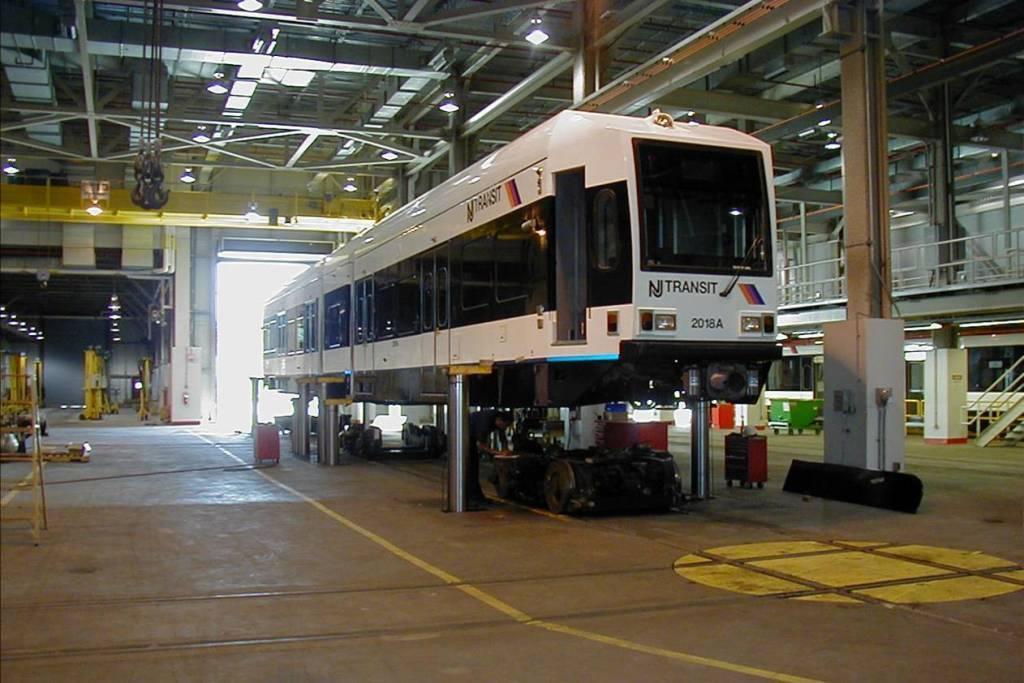In one or two sentences, can you explain what this image depicts? In this image I can see the vehicle which is in white and black color. I can see many machines and some objects. To the right I can see the railing and the trolley. To the left I can see the rods. These are inside the shed. I can see many lights at the top. 